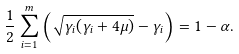Convert formula to latex. <formula><loc_0><loc_0><loc_500><loc_500>\frac { 1 } { 2 } \sum _ { i = 1 } ^ { m } \left ( \sqrt { \gamma _ { i } ( \gamma _ { i } + 4 \mu ) } - \gamma _ { i } \right ) = 1 - \alpha .</formula> 